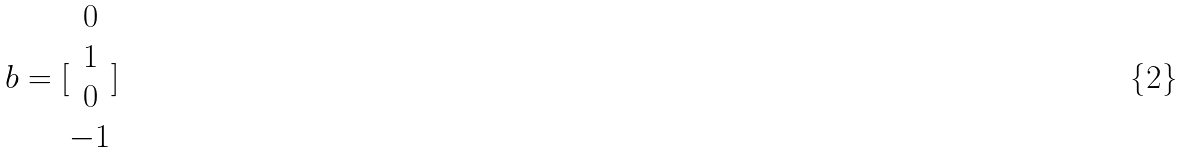<formula> <loc_0><loc_0><loc_500><loc_500>b = [ \begin{matrix} 0 \\ 1 \\ 0 \\ - 1 \end{matrix} ]</formula> 